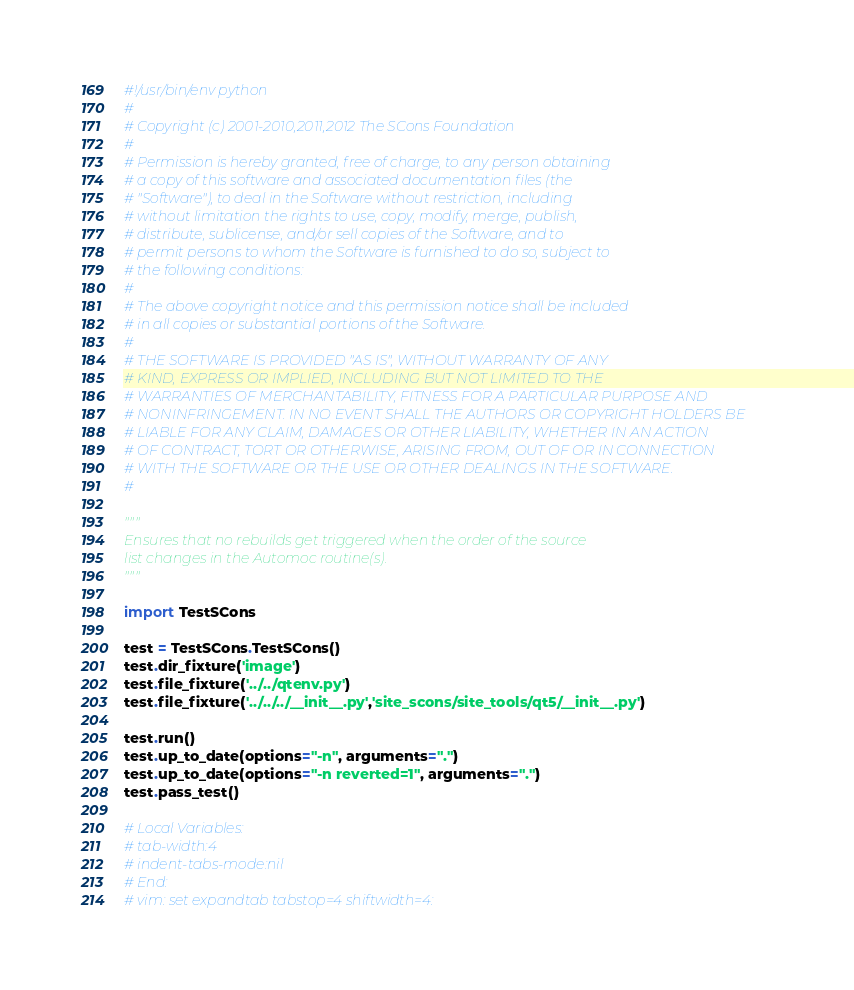<code> <loc_0><loc_0><loc_500><loc_500><_Python_>#!/usr/bin/env python
#
# Copyright (c) 2001-2010,2011,2012 The SCons Foundation
#
# Permission is hereby granted, free of charge, to any person obtaining
# a copy of this software and associated documentation files (the
# "Software"), to deal in the Software without restriction, including
# without limitation the rights to use, copy, modify, merge, publish,
# distribute, sublicense, and/or sell copies of the Software, and to
# permit persons to whom the Software is furnished to do so, subject to
# the following conditions:
#
# The above copyright notice and this permission notice shall be included
# in all copies or substantial portions of the Software.
#
# THE SOFTWARE IS PROVIDED "AS IS", WITHOUT WARRANTY OF ANY
# KIND, EXPRESS OR IMPLIED, INCLUDING BUT NOT LIMITED TO THE
# WARRANTIES OF MERCHANTABILITY, FITNESS FOR A PARTICULAR PURPOSE AND
# NONINFRINGEMENT. IN NO EVENT SHALL THE AUTHORS OR COPYRIGHT HOLDERS BE
# LIABLE FOR ANY CLAIM, DAMAGES OR OTHER LIABILITY, WHETHER IN AN ACTION
# OF CONTRACT, TORT OR OTHERWISE, ARISING FROM, OUT OF OR IN CONNECTION
# WITH THE SOFTWARE OR THE USE OR OTHER DEALINGS IN THE SOFTWARE.
#

"""
Ensures that no rebuilds get triggered when the order of the source
list changes in the Automoc routine(s).
"""

import TestSCons

test = TestSCons.TestSCons()
test.dir_fixture('image')
test.file_fixture('../../qtenv.py')
test.file_fixture('../../../__init__.py','site_scons/site_tools/qt5/__init__.py')

test.run()
test.up_to_date(options="-n", arguments=".")
test.up_to_date(options="-n reverted=1", arguments=".")
test.pass_test()

# Local Variables:
# tab-width:4
# indent-tabs-mode:nil
# End:
# vim: set expandtab tabstop=4 shiftwidth=4:
</code> 